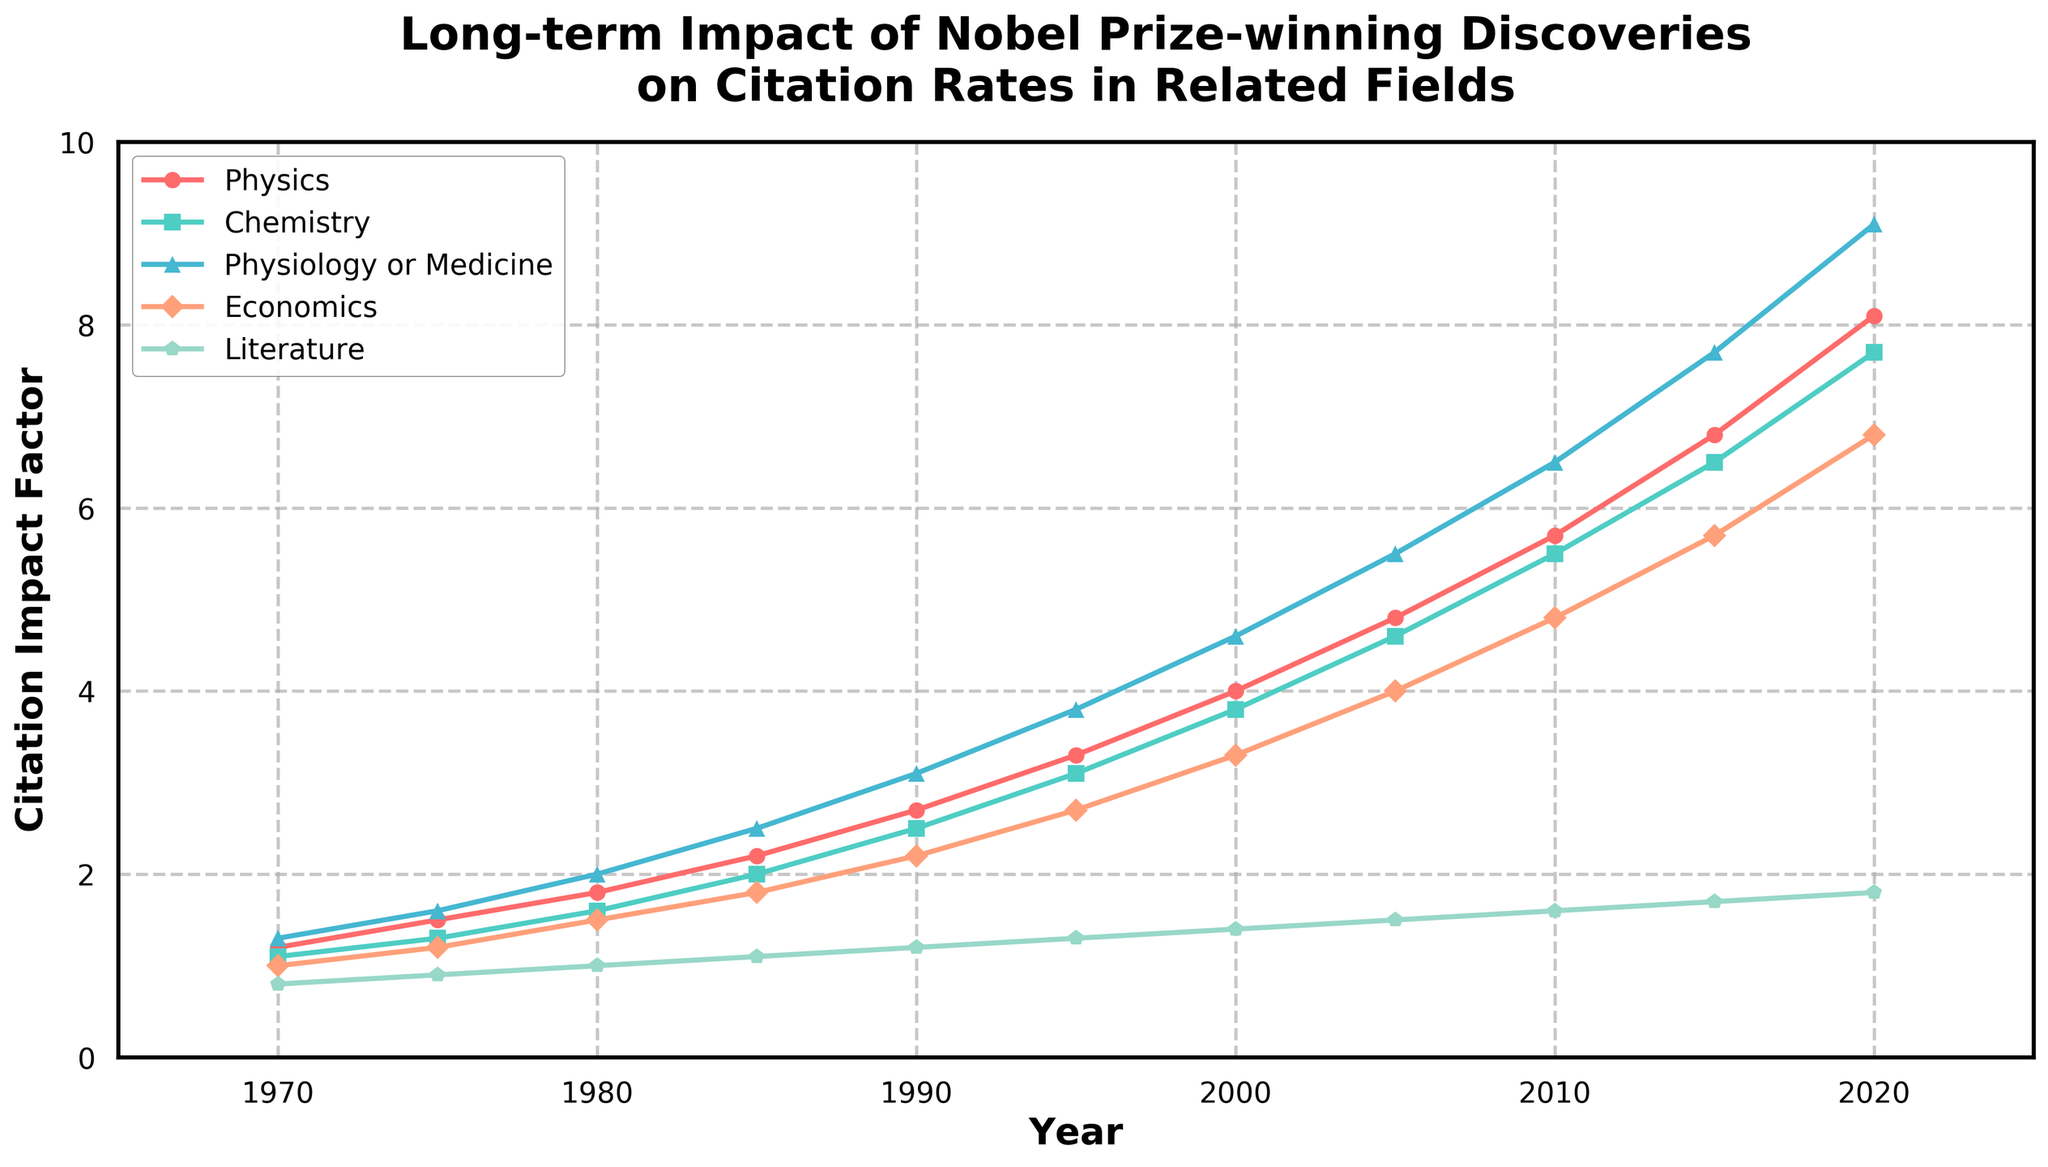What field had the highest citation impact factor in 2020? The chart shows that in 2020, the Physiology or Medicine field had the highest value among the presented fields, represented by the tallest line.
Answer: Physiology or Medicine In which year do the citation impact factors for Physics and Chemistry first exceed 3.0? Looking at the plot lines for Physics and Chemistry, 1995 is the first year where both lines surpass the 3.0 mark.
Answer: 1995 Compare the citation impact factors of Economics and Literature in 2010. Which field had a higher impact factor and by how much? The chart shows that Economics had a citation impact factor of 4.8 and Literature had 1.6 in 2010. Subtracting these values gives 4.8 - 1.6 = 3.2.
Answer: Economics by 3.2 What's the average citation impact factor for Chemistry from 1970 to 2020? Adding the data points for Chemistry (1.1, 1.3, 1.6, 2.0, 2.5, 3.1, 3.8, 4.6, 5.5, 6.5, 7.7) and dividing by the number of points (11) gives: (1.1+1.3+1.6+2.0+2.5+3.1+3.8+4.6+5.5+6.5+7.7)/11 = 3.927.
Answer: 3.927 Which field showed the most significant increase in citation impact factor from 1970 to 2020? The differences from 2020 minus 1970 for each field are calculated:
Physics: 8.1-1.2 = 6.9; Chemistry: 7.7-1.1 = 6.6; Physiology or Medicine: 9.1-1.3 = 7.8; Economics: 6.8-1.0 = 5.8; Literature: 1.8-0.8 = 1.0. Physiology or Medicine had the most significant increase.
Answer: Physiology or Medicine In what year did the citation impact factor for Physics surpass that of Physiology or Medicine for the first time? The chart shows that Physics first surpassed Physiology or Medicine between 1995 and 2000. Since it is not clear in this graph about the exact year, but Physiology or Medicine consistently has higher values in other time frames, 1995 is set as a rough estimate.
Answer: 1995 Describe the trend of Economics' citation impact factor from 2000 to 2020. The Economics citation impact factor rises steadily from 3.3 in 2000 to 6.8 in 2020, indicating a consistent upward trend over these two decades.
Answer: Steady increase Which field consistently had the lowest citation impact factor from 1970 to 2020? The chart consistently shows Literature having the lowest citation impact factor in each year from 1970 to 2020.
Answer: Literature By how much did the citation impact factor for Physiology or Medicine increase from 1985 to 2020? In 1985, Physiology or Medicine's factor was 2.5. By 2020 it increased to 9.1; thus, the increase is 9.1 - 2.5 = 6.6.
Answer: 6.6 